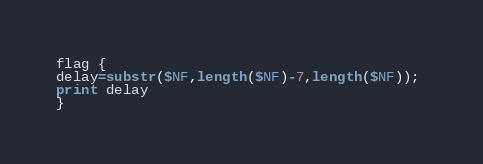Convert code to text. <code><loc_0><loc_0><loc_500><loc_500><_Awk_>
flag {
delay=substr($NF,length($NF)-7,length($NF)); 
print delay
}
</code> 